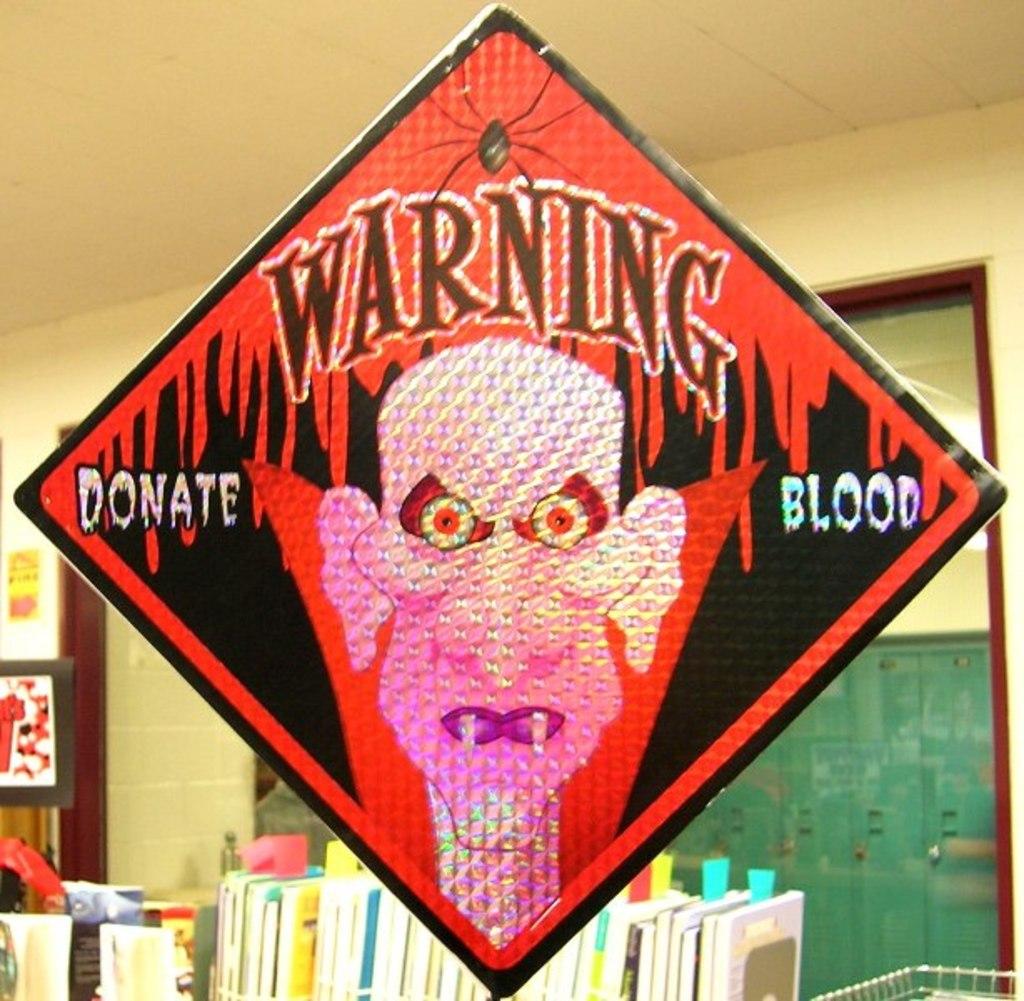What is the sign with the vampire saying?
Ensure brevity in your answer.  Warning donate blood. What is being asked to donate?
Make the answer very short. Blood. 